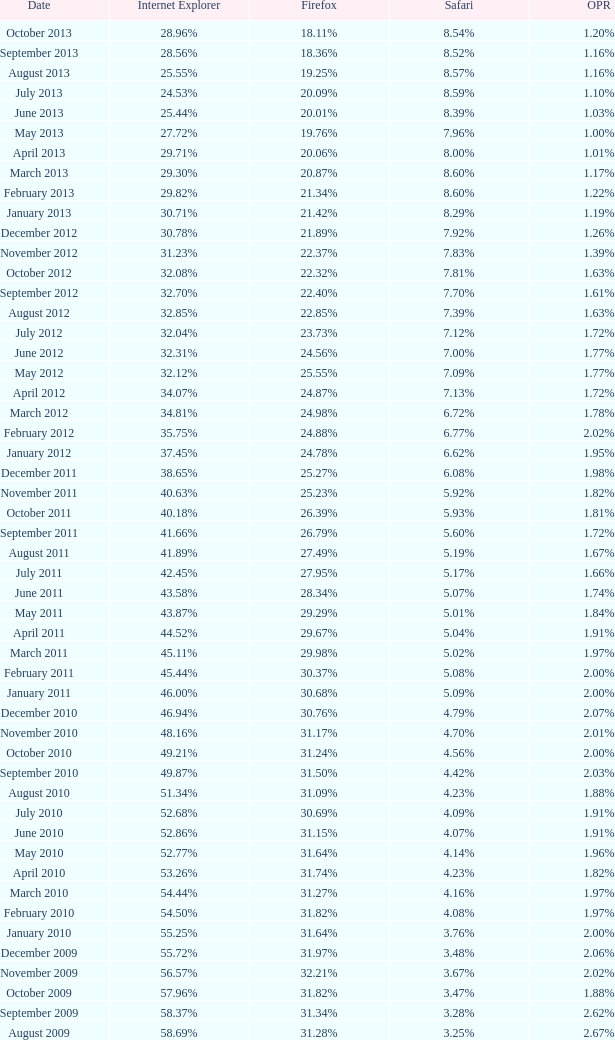What percentage of browsers were using Safari during the period in which 31.27% were using Firefox? 4.16%. 